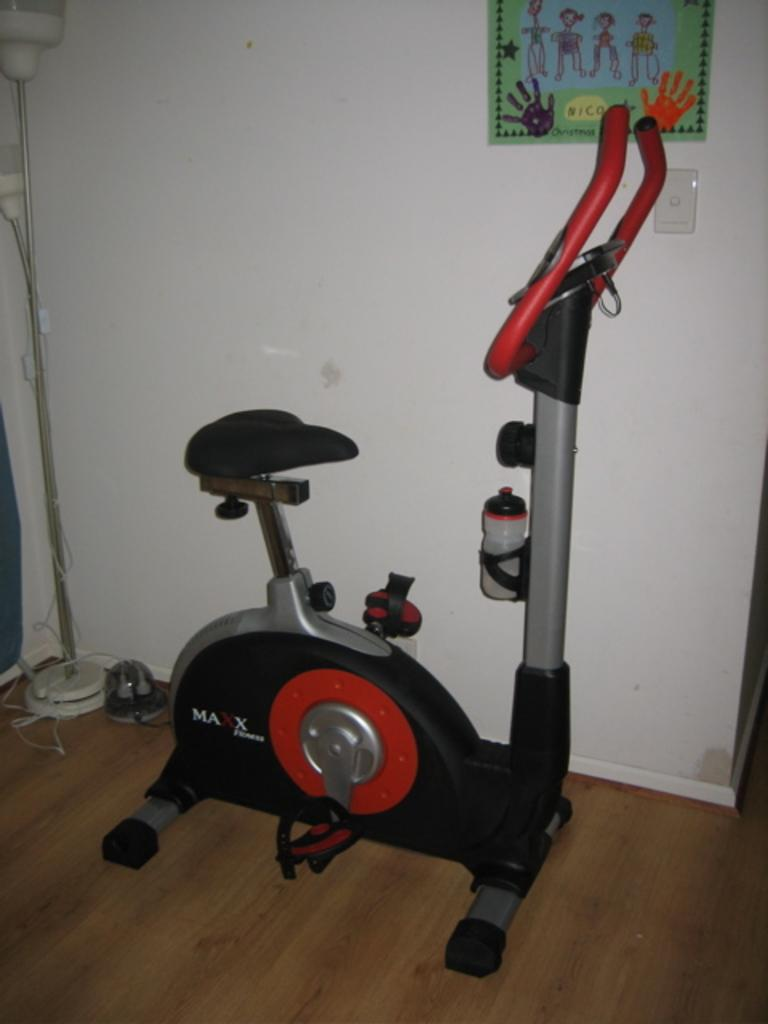What type of equipment is present in the image? There is an exercise machine in the image. What else can be seen in the image besides the exercise machine? There is a stand and other objects visible in the image. What is on the wall in the background of the image? There is a poster on the wall in the background of the image. What type of butter is being used to create the lace pattern on the music sheet in the image? There is no butter, lace, or music sheet present in the image. 